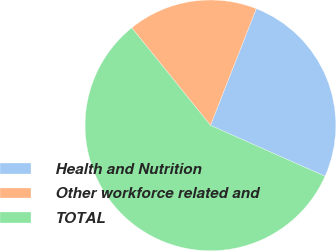Convert chart to OTSL. <chart><loc_0><loc_0><loc_500><loc_500><pie_chart><fcel>Health and Nutrition<fcel>Other workforce related and<fcel>TOTAL<nl><fcel>25.7%<fcel>16.76%<fcel>57.54%<nl></chart> 